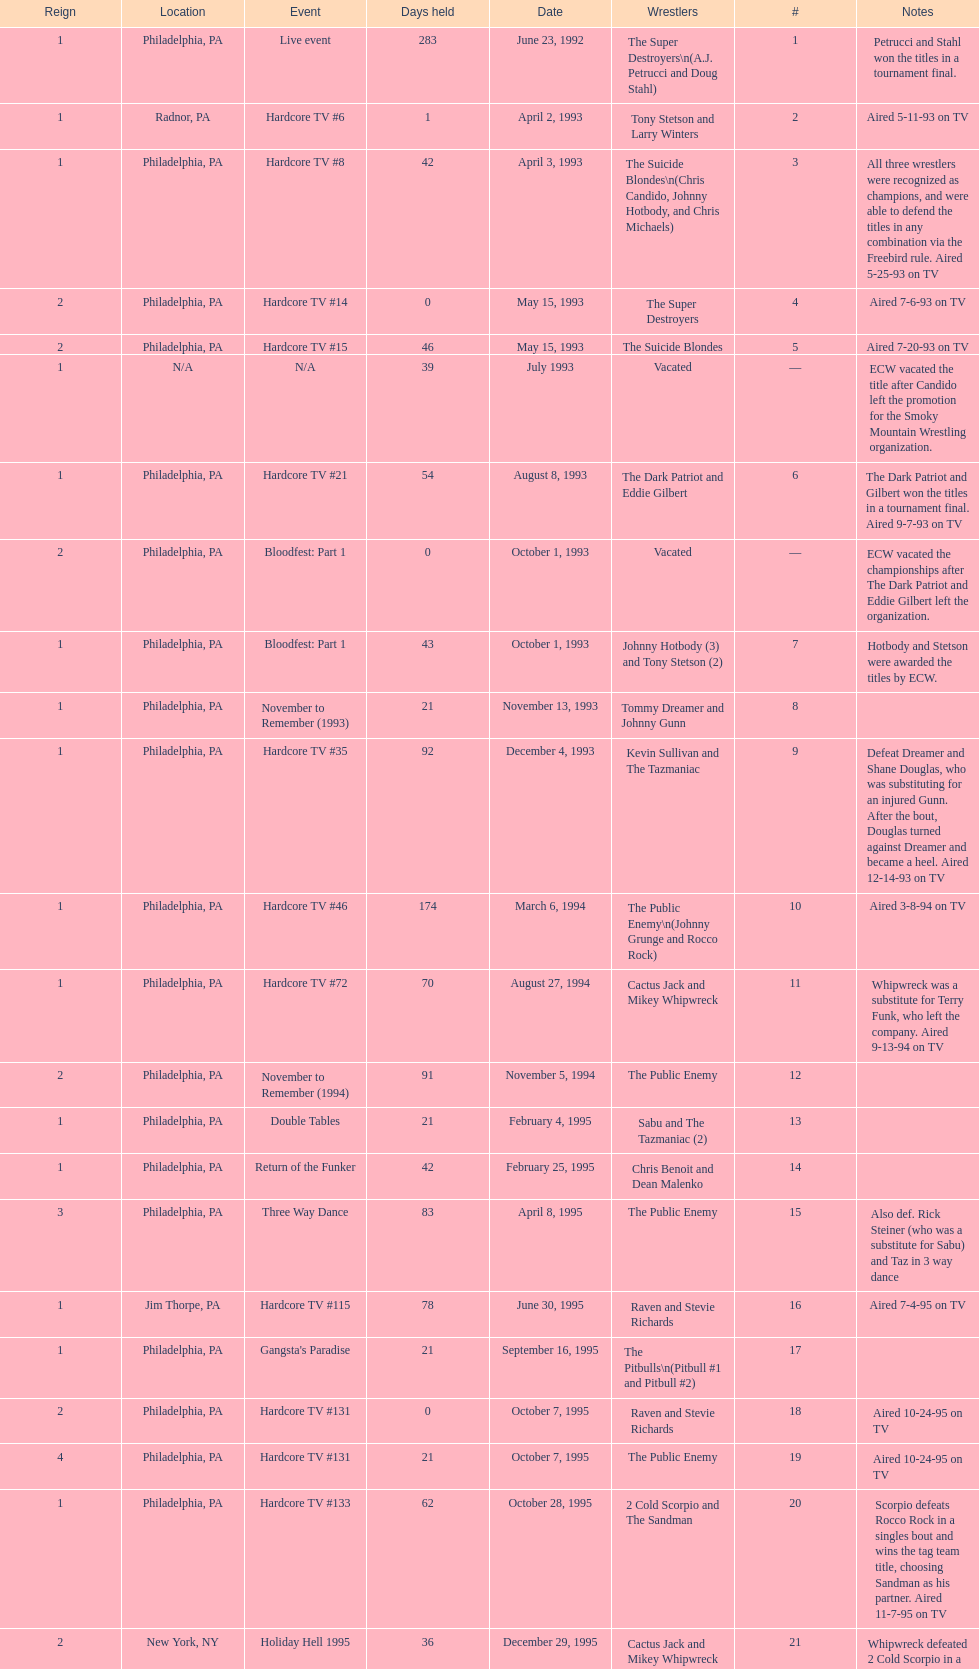What is the next event after hardcore tv #15? Hardcore TV #21. 